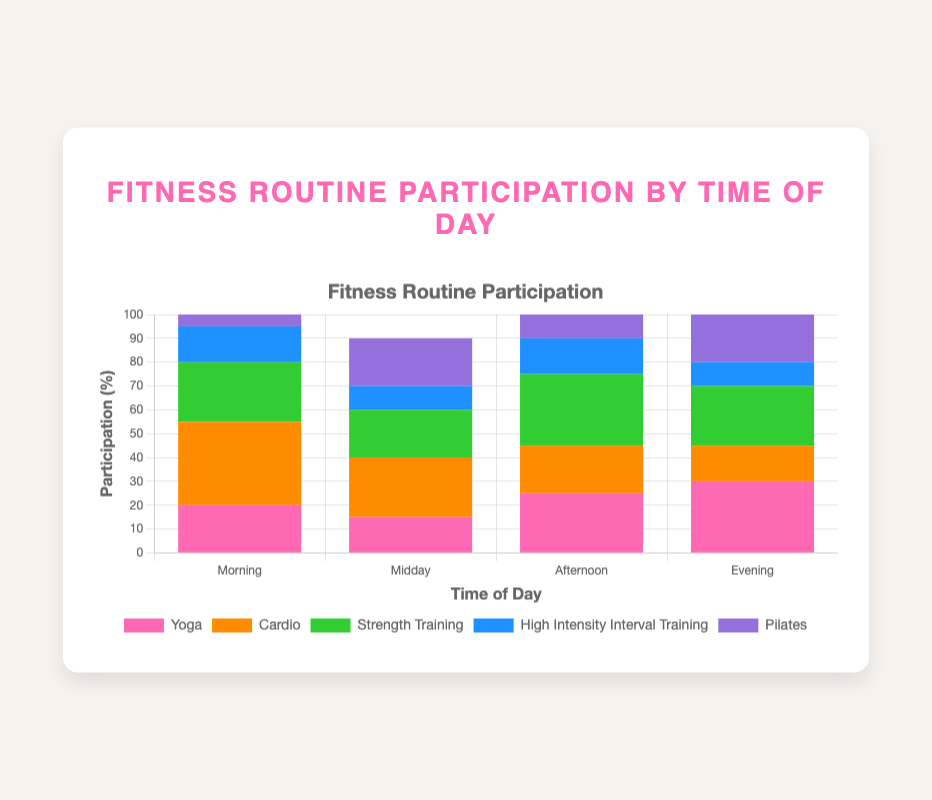Which time of day has the highest participation in Yoga? Looking at the bar heights for Yoga across different times of day, the Evening has the tallest bar for Yoga.
Answer: Evening What is the total participation percentage for Cardio and Strength Training in the Morning? In the Morning, Cardio has a 35% participation rate and Strength Training has a 25% rate. Their sum is 35 + 25 = 60.
Answer: 60 Is Pilates more popular in the Midday or the Afternoon? Comparing the bar heights for Pilates in the Midday and Afternoon, the Midday bar is higher at 20% compared to 10% in the Afternoon.
Answer: Midday What is the difference in High-Intensity Interval Training participation between the Morning and the Evening? The participation for High-Intensity Interval Training in the Morning is 15%, and in the Evening, it is 10%. The difference is 15 - 10 = 5.
Answer: 5 Which exercise type has the lowest participation in the Morning? Looking at the bar heights for each exercise type in the Morning, Pilates has the shortest bar at 5%.
Answer: Pilates How does the participation for Yoga compare between the Afternoon and Midday? The participation for Yoga in the Afternoon is 25%, while in the Midday, it is 15%. Thus, Yoga participation is higher in the Afternoon.
Answer: Afternoon Calculate the average participation percentage for Pilates throughout the day. The participation percentages for Pilates are 5% (Morning), 20% (Midday), 10% (Afternoon), and 20% (Evening). The average is (5 + 20 + 10 + 20) / 4 = 13.75.
Answer: 13.75 Which time of day has the highest total participation across all exercise types? Summing up participation percentages for all exercises at each time of day: 
Morning: 20 + 35 + 25 + 15 + 5 = 100 
Midday: 15 + 25 + 20 + 10 + 20 = 90 
Afternoon: 25 + 20 + 30 + 15 + 10 = 100 
Evening: 30 + 15 + 25 + 10 + 20 = 100 
The total participation is highest and equal for Morning, Afternoon, and Evening at 100%.
Answer: Morning, Afternoon, Evening 